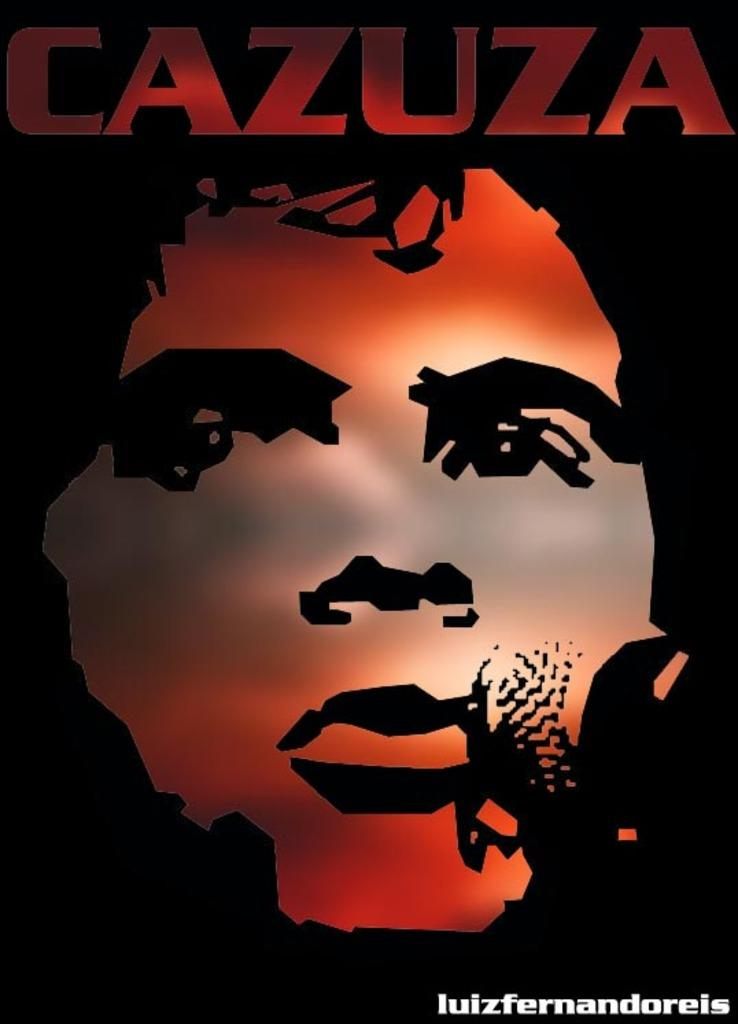What type of visual is depicted in the image? The image is a poster. What is the main subject of the poster? There is a face of a person on the poster. What type of furniture is visible in the image? There is no furniture present in the image, as it is a poster featuring a person's face. Can you see any clams in the image? There are no clams present in the image, as it features a person's face on a poster. 